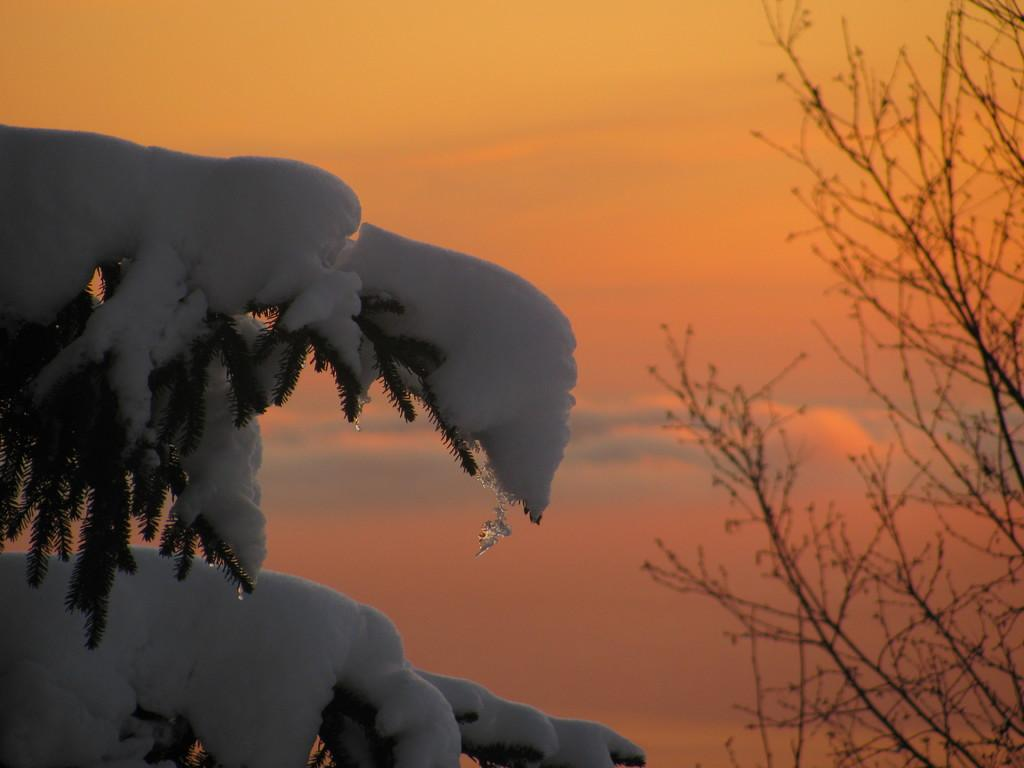What type of vegetation can be seen in the image? There are trees in the image. What is covering the trees in the image? There is snow on the trees. What is visible at the top of the image? The sky is visible at the top of the image. What can be seen in the sky in the image? There are clouds in the sky. Can you tell me how many experts are swimming in the river in the image? There is no river or experts swimming in the image; it features trees with snow and a cloudy sky. 